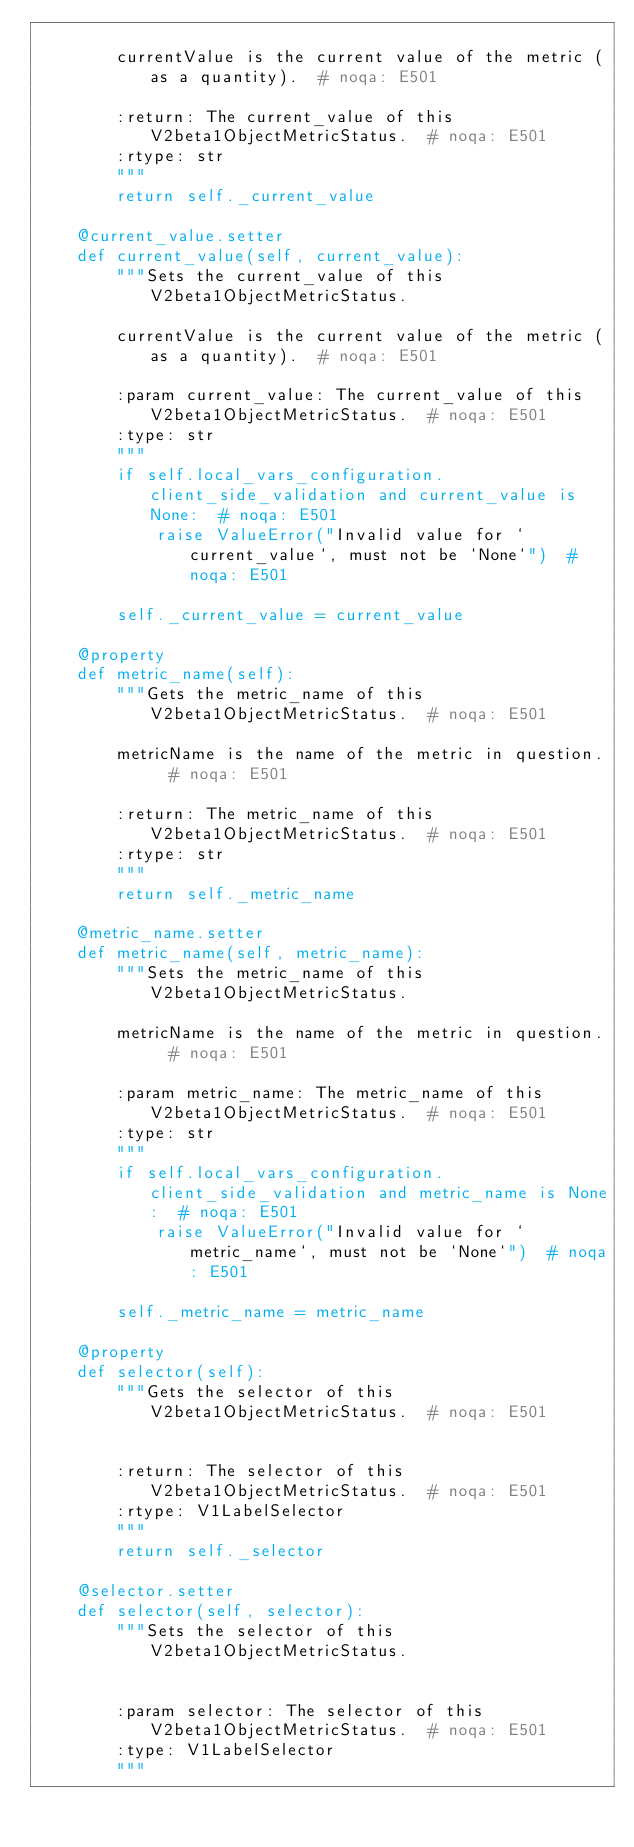Convert code to text. <code><loc_0><loc_0><loc_500><loc_500><_Python_>
        currentValue is the current value of the metric (as a quantity).  # noqa: E501

        :return: The current_value of this V2beta1ObjectMetricStatus.  # noqa: E501
        :rtype: str
        """
        return self._current_value

    @current_value.setter
    def current_value(self, current_value):
        """Sets the current_value of this V2beta1ObjectMetricStatus.

        currentValue is the current value of the metric (as a quantity).  # noqa: E501

        :param current_value: The current_value of this V2beta1ObjectMetricStatus.  # noqa: E501
        :type: str
        """
        if self.local_vars_configuration.client_side_validation and current_value is None:  # noqa: E501
            raise ValueError("Invalid value for `current_value`, must not be `None`")  # noqa: E501

        self._current_value = current_value

    @property
    def metric_name(self):
        """Gets the metric_name of this V2beta1ObjectMetricStatus.  # noqa: E501

        metricName is the name of the metric in question.  # noqa: E501

        :return: The metric_name of this V2beta1ObjectMetricStatus.  # noqa: E501
        :rtype: str
        """
        return self._metric_name

    @metric_name.setter
    def metric_name(self, metric_name):
        """Sets the metric_name of this V2beta1ObjectMetricStatus.

        metricName is the name of the metric in question.  # noqa: E501

        :param metric_name: The metric_name of this V2beta1ObjectMetricStatus.  # noqa: E501
        :type: str
        """
        if self.local_vars_configuration.client_side_validation and metric_name is None:  # noqa: E501
            raise ValueError("Invalid value for `metric_name`, must not be `None`")  # noqa: E501

        self._metric_name = metric_name

    @property
    def selector(self):
        """Gets the selector of this V2beta1ObjectMetricStatus.  # noqa: E501


        :return: The selector of this V2beta1ObjectMetricStatus.  # noqa: E501
        :rtype: V1LabelSelector
        """
        return self._selector

    @selector.setter
    def selector(self, selector):
        """Sets the selector of this V2beta1ObjectMetricStatus.


        :param selector: The selector of this V2beta1ObjectMetricStatus.  # noqa: E501
        :type: V1LabelSelector
        """
</code> 